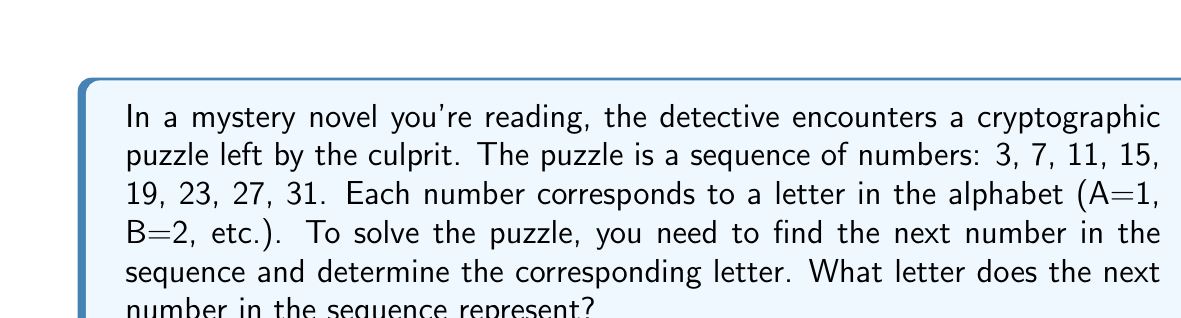Give your solution to this math problem. To solve this puzzle, we need to follow these steps:

1. Recognize the pattern in the sequence:
   The difference between consecutive terms is constant.
   $$7 - 3 = 4$$
   $$11 - 7 = 4$$
   $$15 - 11 = 4$$
   And so on...

2. Determine the arithmetic sequence:
   This is an arithmetic sequence with a common difference of 4.
   The general formula for an arithmetic sequence is:
   $$a_n = a_1 + (n-1)d$$
   Where $a_n$ is the nth term, $a_1$ is the first term, n is the position, and d is the common difference.

3. Find the next number in the sequence:
   The given sequence has 8 terms, so we need to find the 9th term.
   $$a_9 = 3 + (9-1)4 = 3 + 32 = 35$$

4. Convert the number to its corresponding letter:
   Since A=1, B=2, etc., we need to find the 35th letter in the alphabet.
   The alphabet has 26 letters, so we need to wrap around:
   $$35 - 26 = 9$$
   The 9th letter of the alphabet is I.

Therefore, the next number in the sequence is 35, which corresponds to the letter I.
Answer: I 